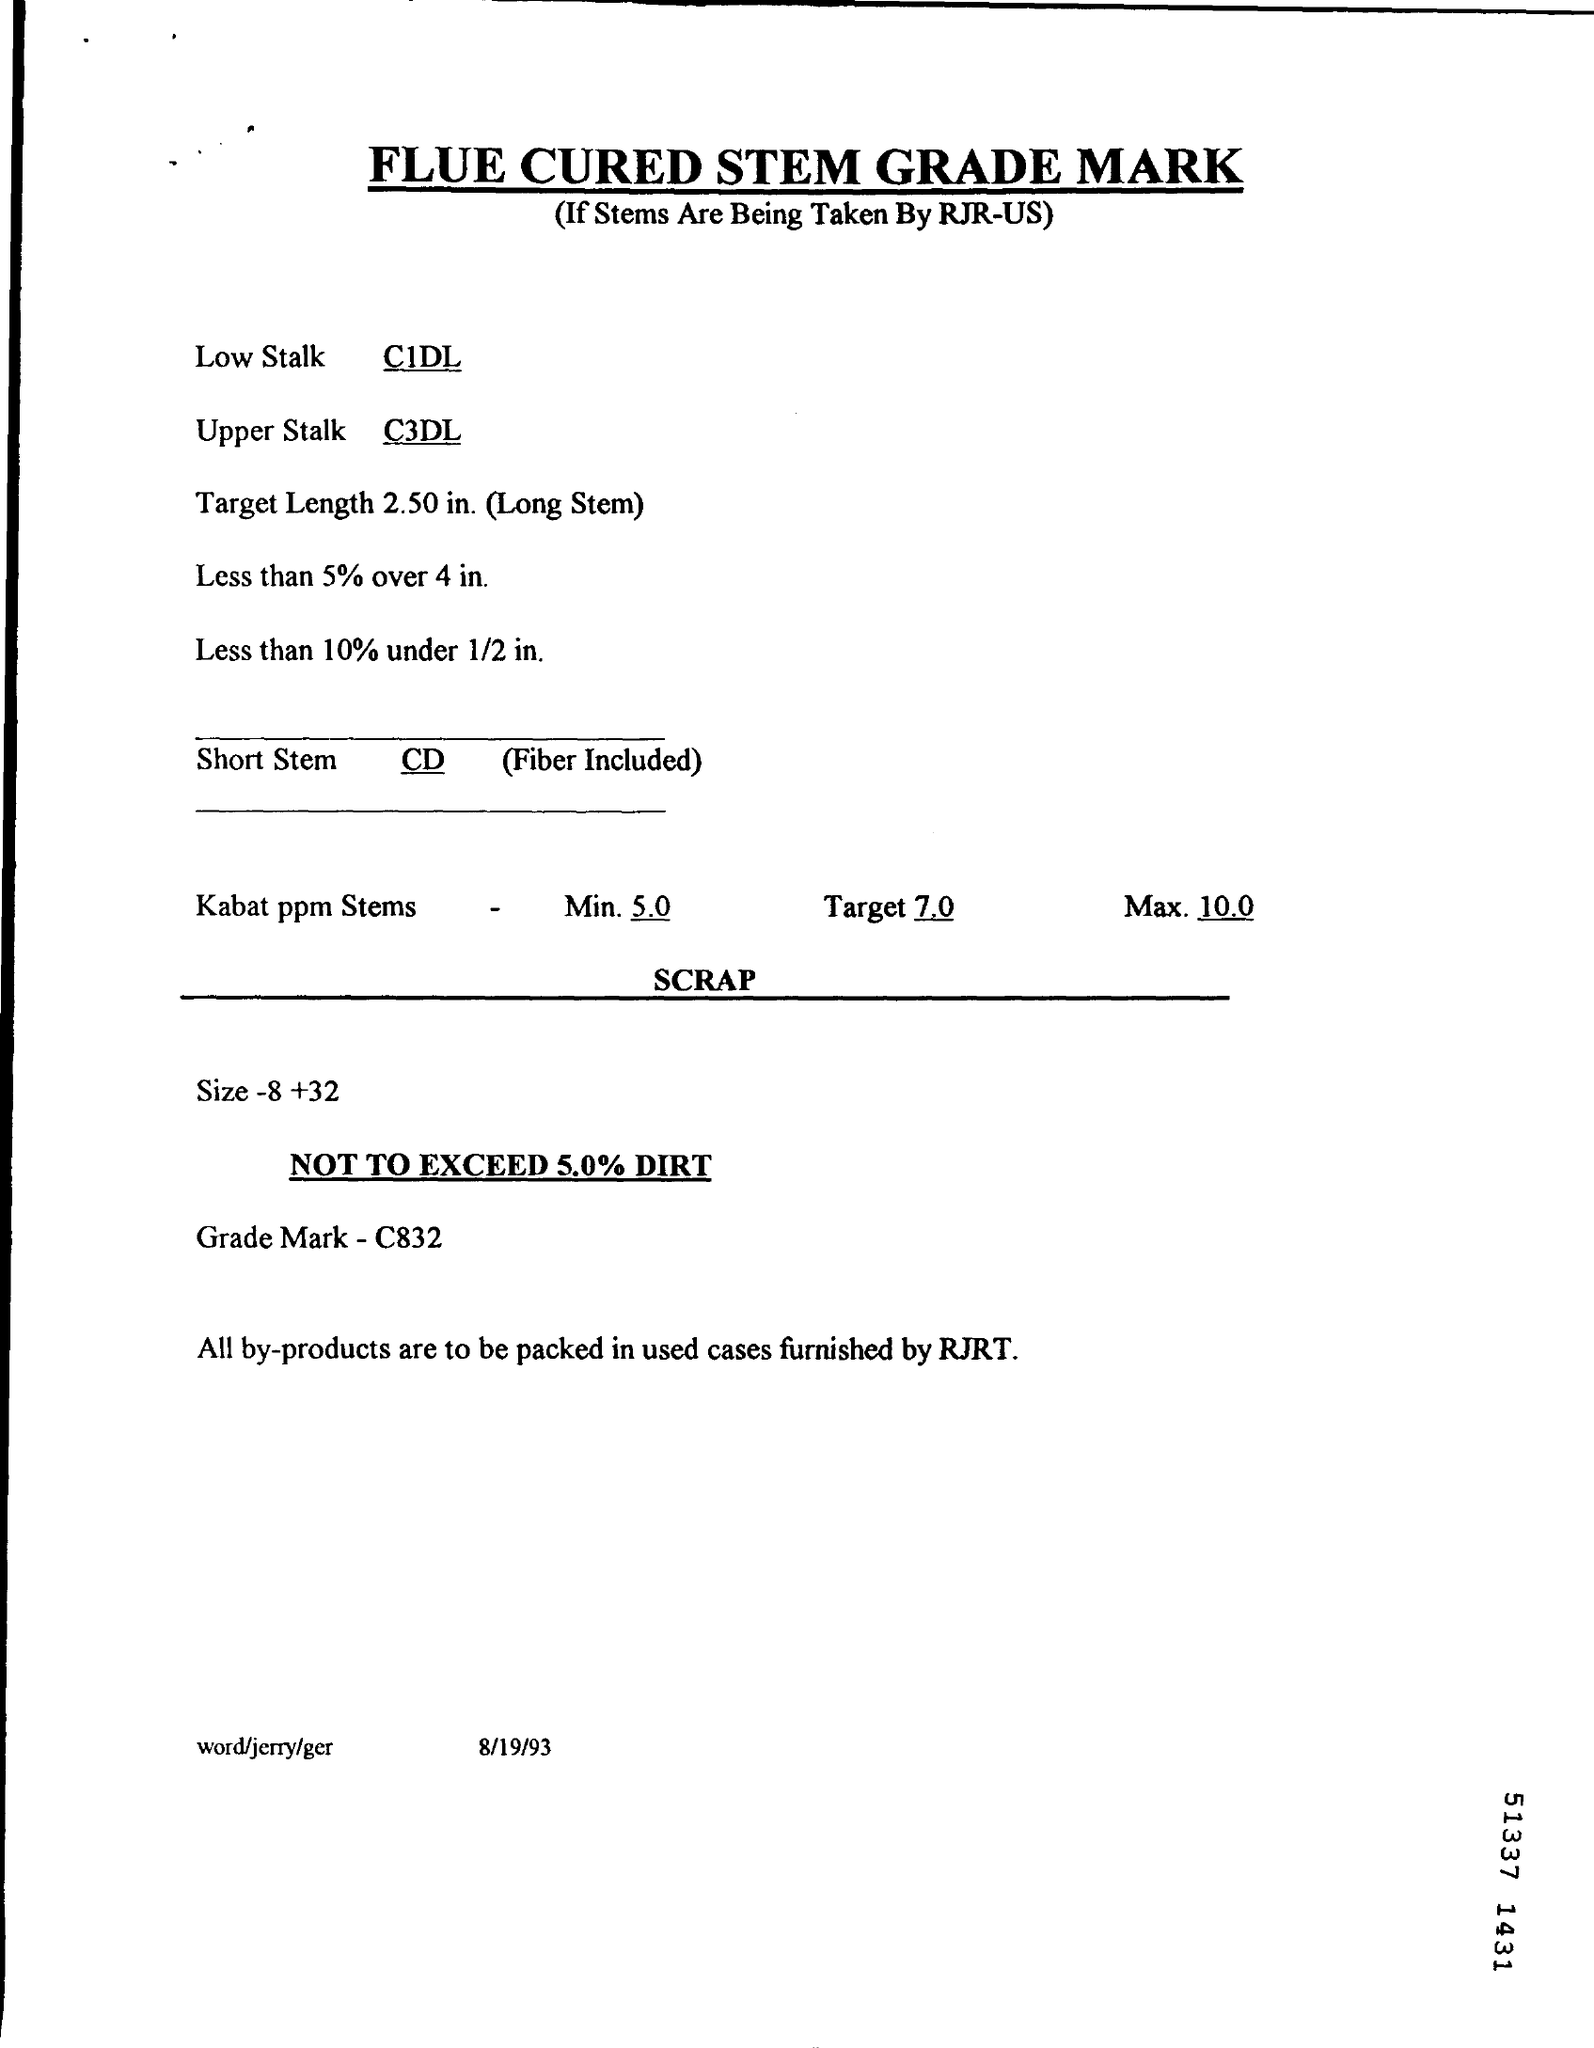Indicate a few pertinent items in this graphic. The grade mark mentioned is C832. The document is dated August 19, 1993. 